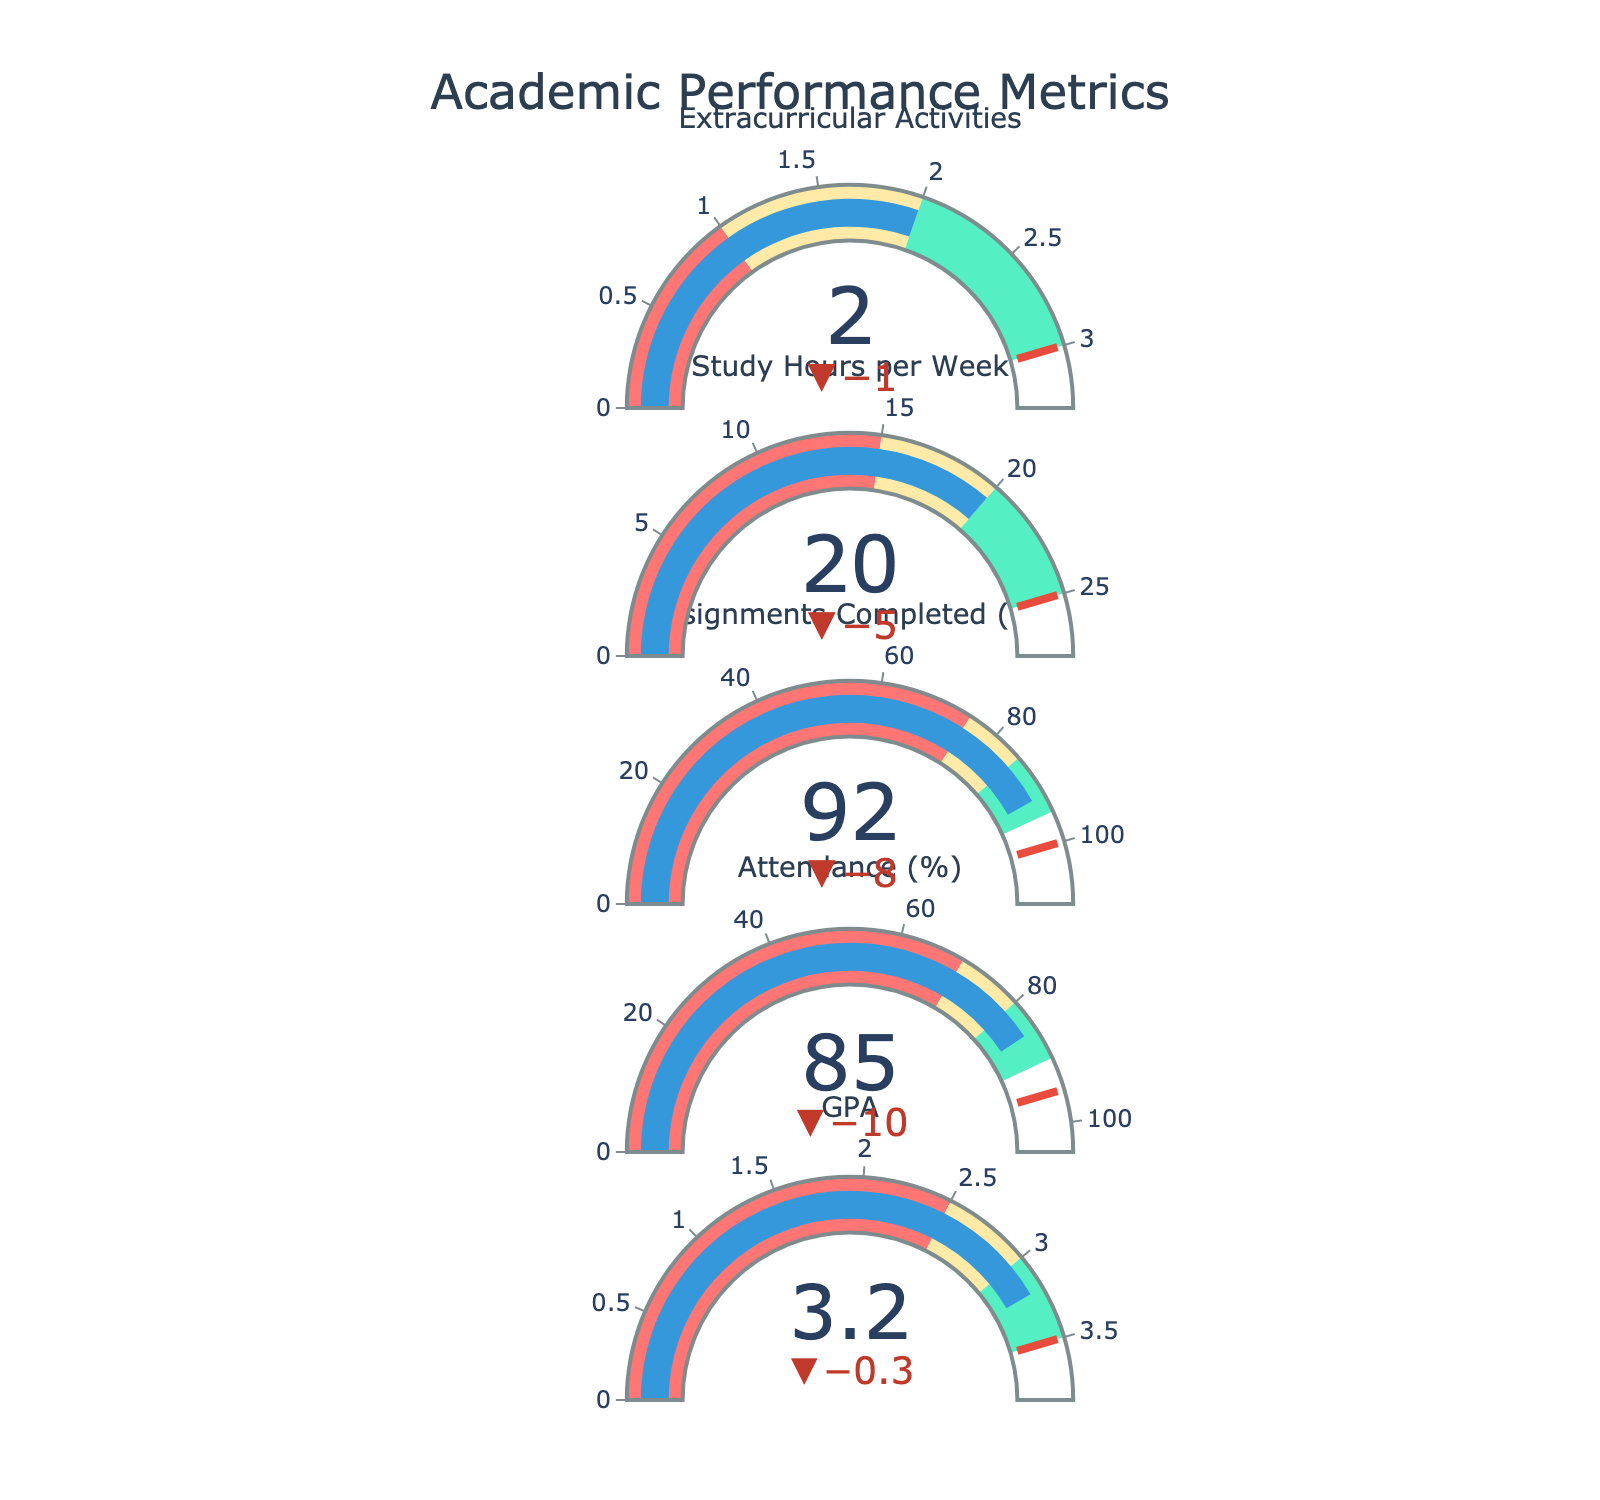What is the title of the chart? The title of the chart appears at the top and is written in large font to catch the viewer's attention. The title usually describes the main topic of the figure.
Answer: Academic Performance Metrics How does the actual GPA compare with the target GPA? To compare, we look at the value indicators showing the actual and target GPA. The actual GPA is 3.2, and the target GPA is 3.5.
Answer: The actual GPA is lower than the target GPA Which metric has the highest actual value in percentage terms? We need to look at the indicators for Attendance (%) and Assignments Completed (%), focusing on their actual values. The actual values are 85% and 92%, respectively.
Answer: Assignments Completed (%) What is the difference between the Actual and Target Attendance (%)? Subtract the actual value of Attendance (85%) from its target value (95%). The difference \( 95 - 85 = 10 \).
Answer: 10% For Study Hours per Week, the actual value lies in which performance range (Poor, Satisfactory, Good)? Compare the actual value of Study Hours per Week (20 hours) against the Poor (15 hours), Satisfactory (20 hours), and Good (25 hours) ranges.
Answer: Satisfactory For which metric is the delta (difference between actual and target) the smallest? Calculating the delta for each metric: GPA (3.5 - 3.2 = 0.3), Attendance (95 - 85 = 10), Assignments Completed (100 - 92 = 8), Study Hours (25 - 20 = 5), Extracurricular Activities (3 - 2 = 1). The smallest delta is for GPA.
Answer: GPA What performance range color represents 'Poor' in the chart? The 'Poor' range is represented by the first segment of the bullet gauge. It is colored light red.
Answer: Light red What metric shows the best performance in terms of completing its target value? Compare the deltas for each metric, where the smallest delta value closest to the target indicates the best performance. The assignment completion percentage has the smallest delta (8%).
Answer: Assignments Completed (%) On average, how far are the actual values from their target values across all metrics? Calculate the differences: GPA (0.3), Attendance (10), Assignments Completed (8), Study Hours (5), Extracurricular (1). Sum these deltas and divide by the number of metrics: \( (0.3 + 10 + 8 + 5 + 1) / 5 = 4.66 \).
Answer: 4.66 